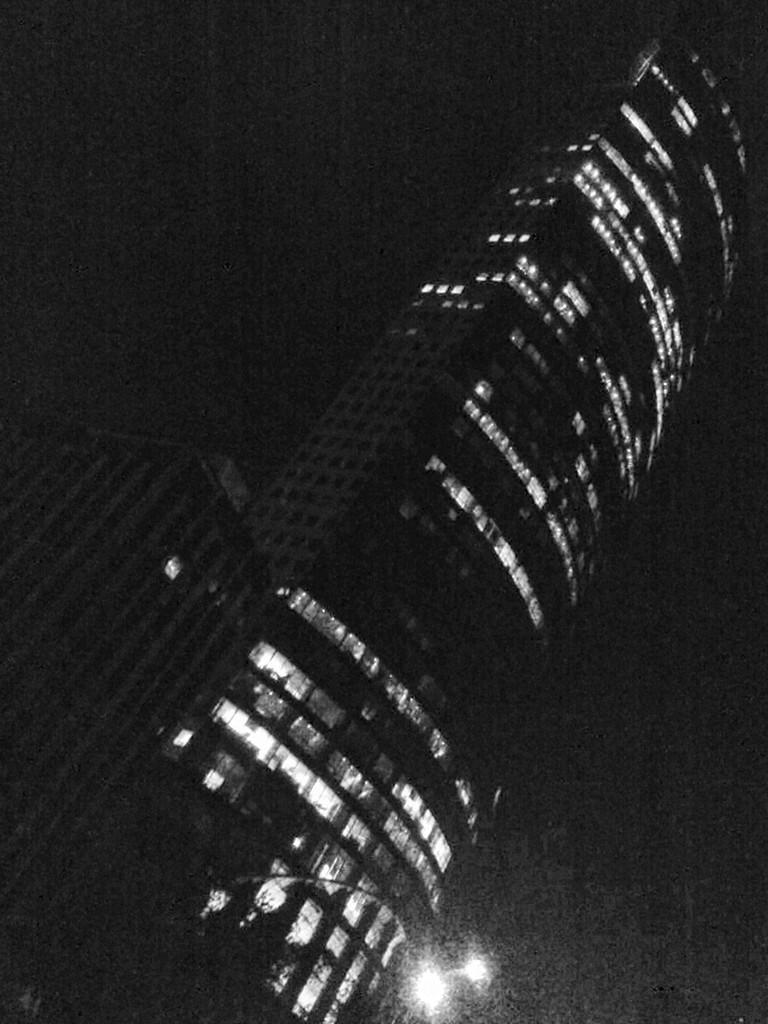What type of structures are present in the image? There are buildings in the image. What architectural feature can be seen in the buildings? There are windows in the image. What can be seen illuminating the scene in the image? There is a light visible in the image. What is the color of the background in the image? The background of the image is dark. Can you tell me how many nerves are visible in the image? There are no nerves present in the image; it features buildings, windows, a light, and a dark background. What type of cracker is being used to prop open the cellar door in the image? There is no cellar or cracker present in the image. 